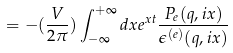<formula> <loc_0><loc_0><loc_500><loc_500>= - ( \frac { V } { 2 \pi } ) \int ^ { + \infty } _ { - \infty } d x e ^ { x t } \frac { P _ { e } ( { q } , i x ) } { \epsilon ^ { ( e ) } ( { q } , i x ) }</formula> 